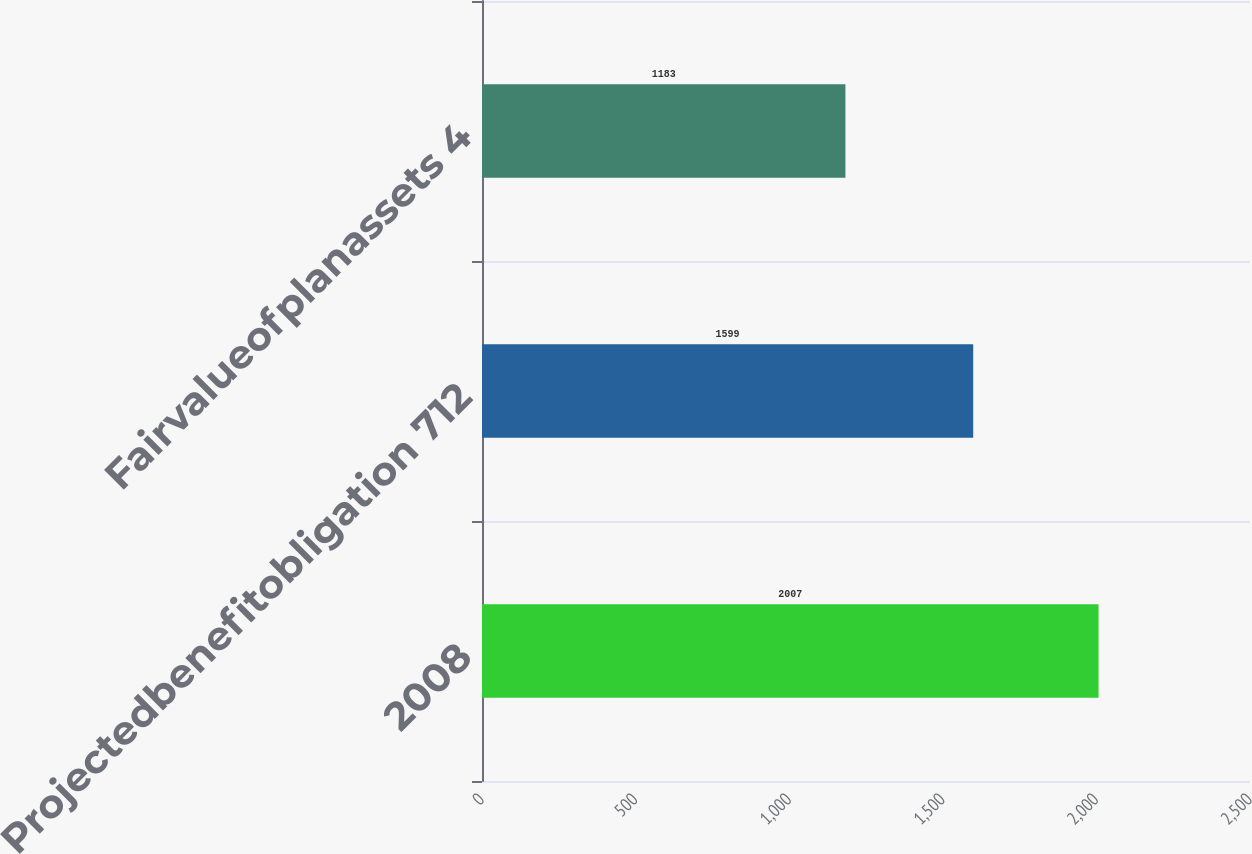Convert chart. <chart><loc_0><loc_0><loc_500><loc_500><bar_chart><fcel>2008<fcel>Projectedbenefitobligation 712<fcel>Fairvalueofplanassets 4<nl><fcel>2007<fcel>1599<fcel>1183<nl></chart> 